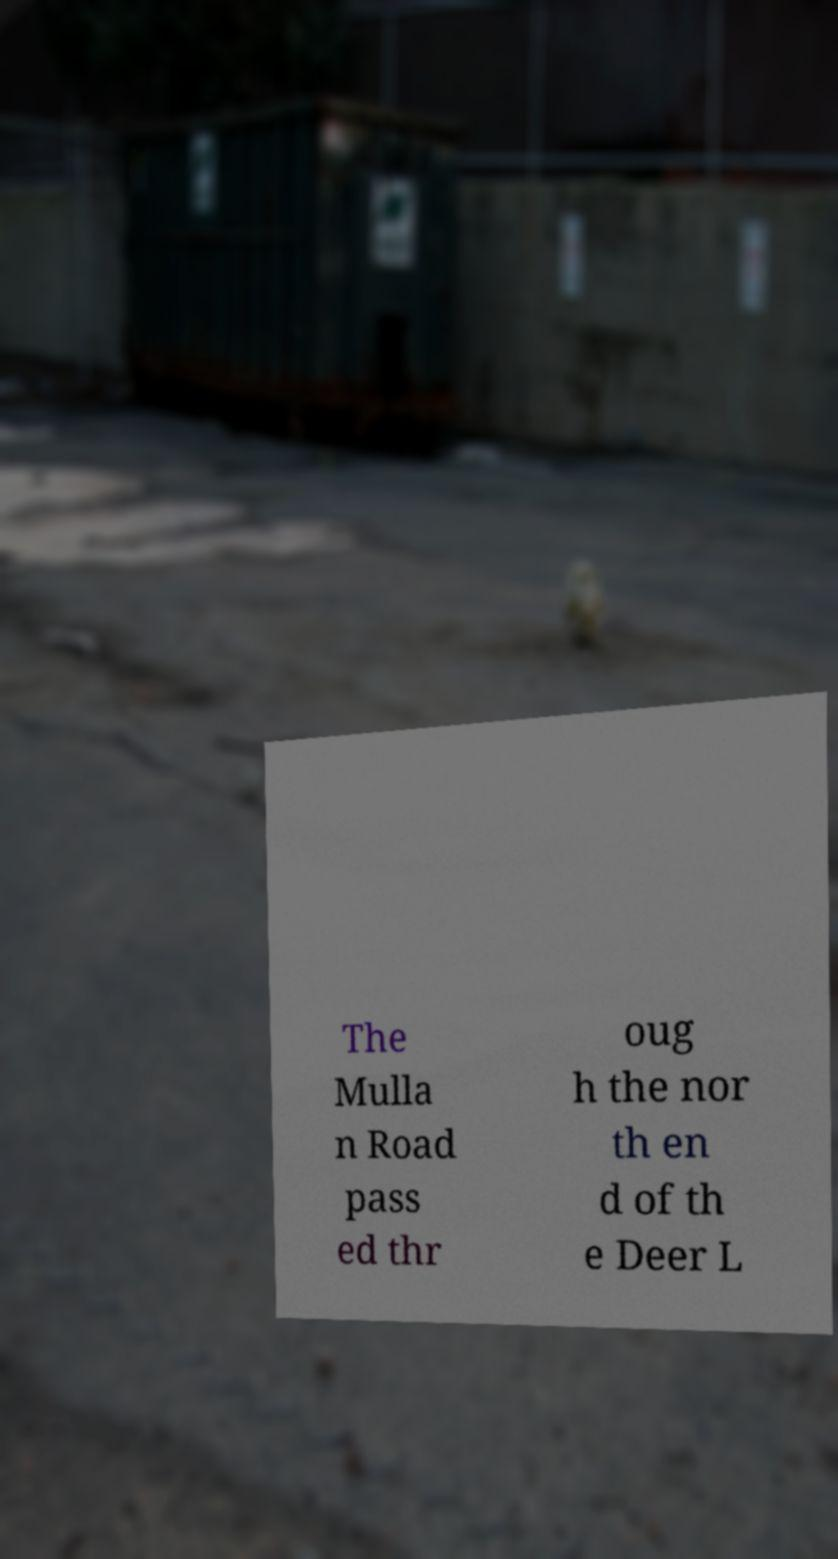Please read and relay the text visible in this image. What does it say? The Mulla n Road pass ed thr oug h the nor th en d of th e Deer L 